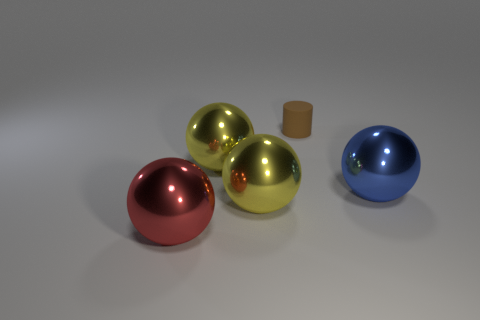Subtract 1 balls. How many balls are left? 3 Subtract all cyan spheres. Subtract all purple cylinders. How many spheres are left? 4 Add 4 blue metallic objects. How many objects exist? 9 Subtract all spheres. How many objects are left? 1 Add 4 red metal objects. How many red metal objects are left? 5 Add 2 cylinders. How many cylinders exist? 3 Subtract 0 purple cylinders. How many objects are left? 5 Subtract all blue shiny spheres. Subtract all small brown cylinders. How many objects are left? 3 